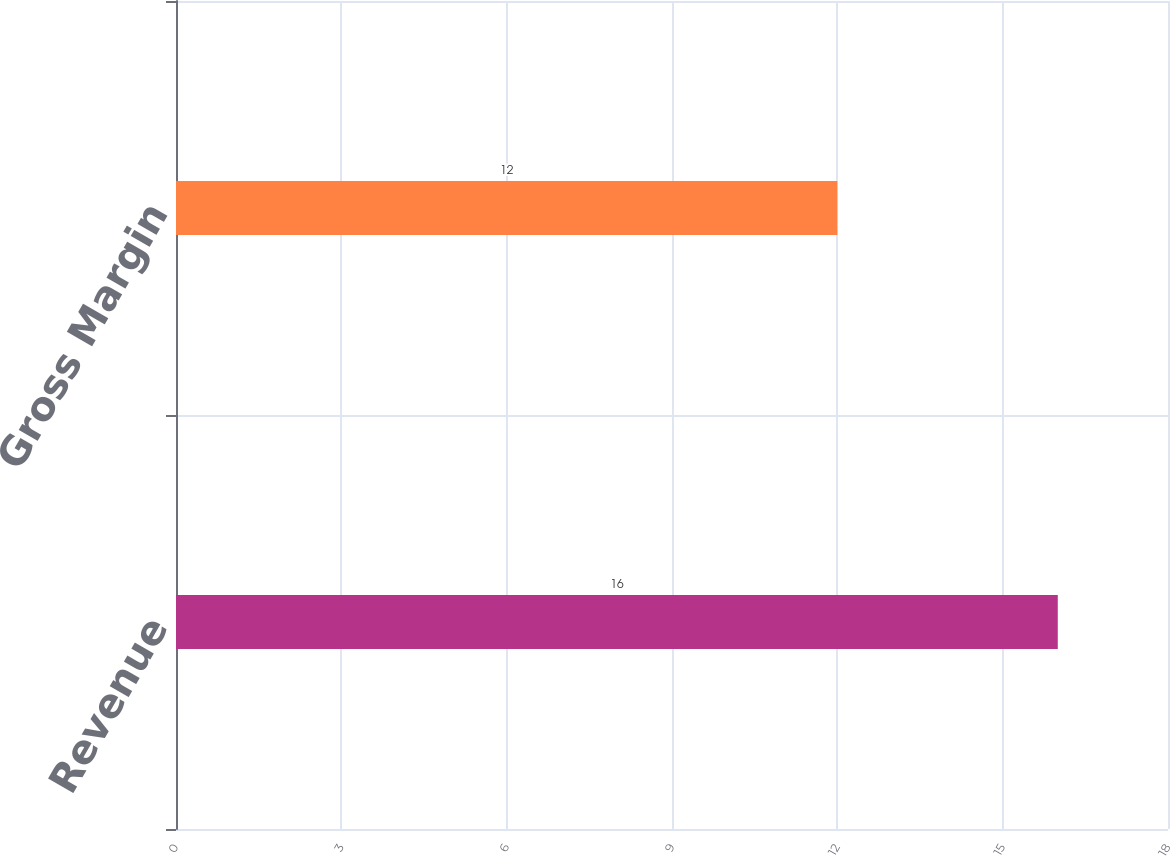Convert chart to OTSL. <chart><loc_0><loc_0><loc_500><loc_500><bar_chart><fcel>Revenue<fcel>Gross Margin<nl><fcel>16<fcel>12<nl></chart> 